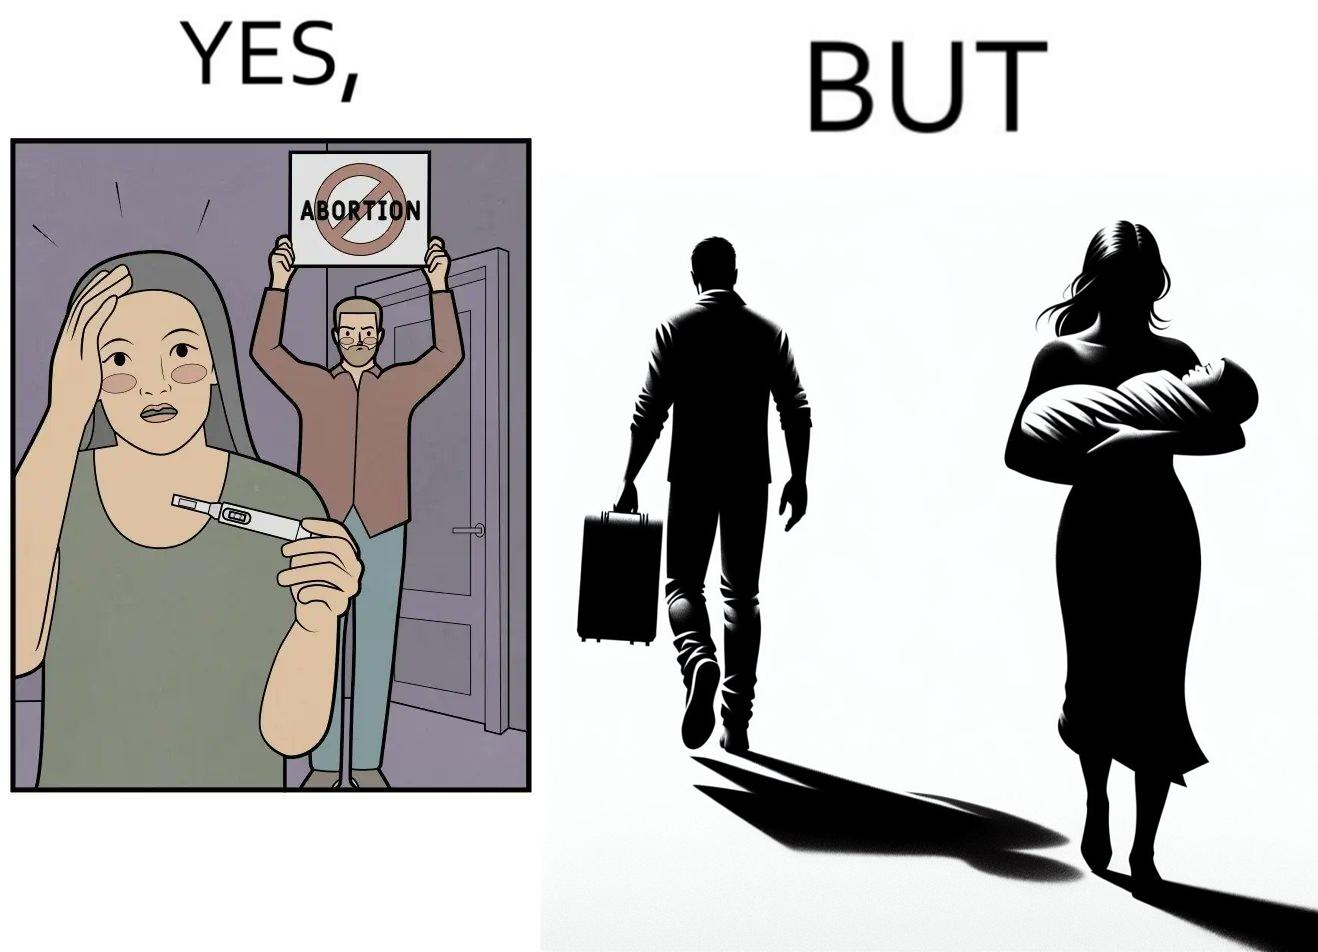What makes this image funny or satirical? The images are ironic, since they show how men protest against abortion of babies but they choose to leave instead of taking care of the babies once they are born leaving the mother with neither a choice or support for raising a child 